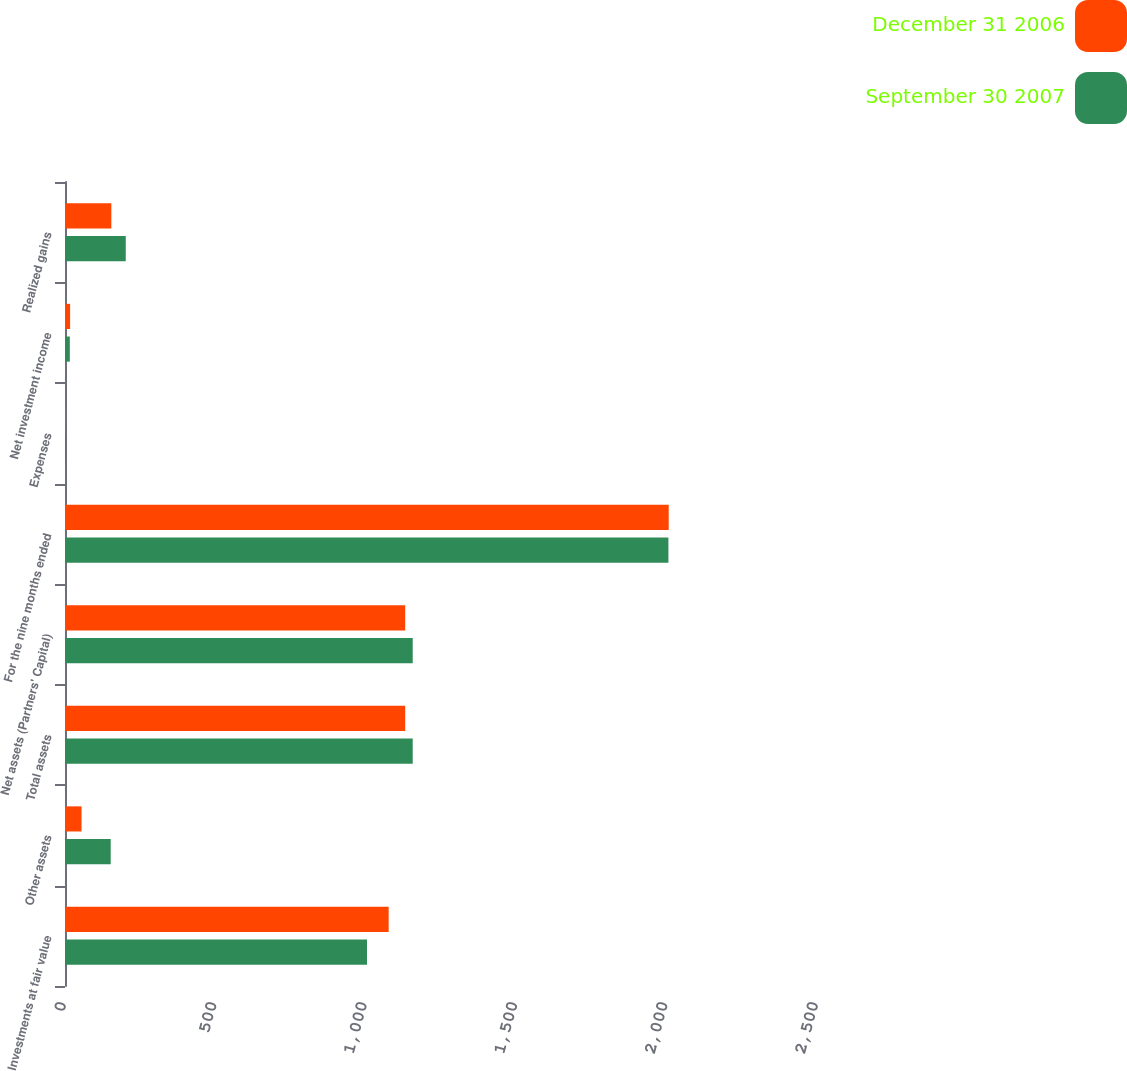Convert chart to OTSL. <chart><loc_0><loc_0><loc_500><loc_500><stacked_bar_chart><ecel><fcel>Investments at fair value<fcel>Other assets<fcel>Total assets<fcel>Net assets (Partners' Capital)<fcel>For the nine months ended<fcel>Expenses<fcel>Net investment income<fcel>Realized gains<nl><fcel>December 31 2006<fcel>1076<fcel>55<fcel>1131<fcel>1131<fcel>2007<fcel>2<fcel>17<fcel>154<nl><fcel>September 30 2007<fcel>1004<fcel>152<fcel>1156<fcel>1156<fcel>2006<fcel>3<fcel>16<fcel>202<nl></chart> 